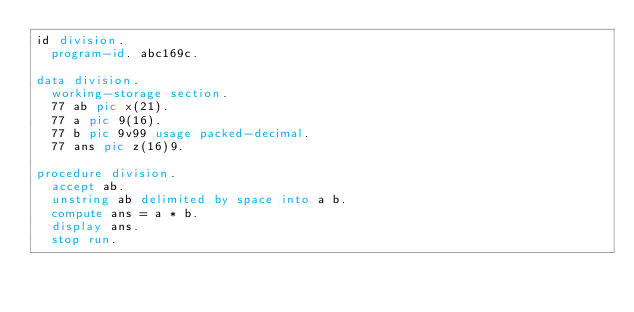<code> <loc_0><loc_0><loc_500><loc_500><_COBOL_>id division.
  program-id. abc169c.

data division.
  working-storage section.
  77 ab pic x(21).
  77 a pic 9(16).
  77 b pic 9v99 usage packed-decimal.
  77 ans pic z(16)9.

procedure division.
  accept ab.
  unstring ab delimited by space into a b.
  compute ans = a * b.
  display ans.
  stop run.
</code> 